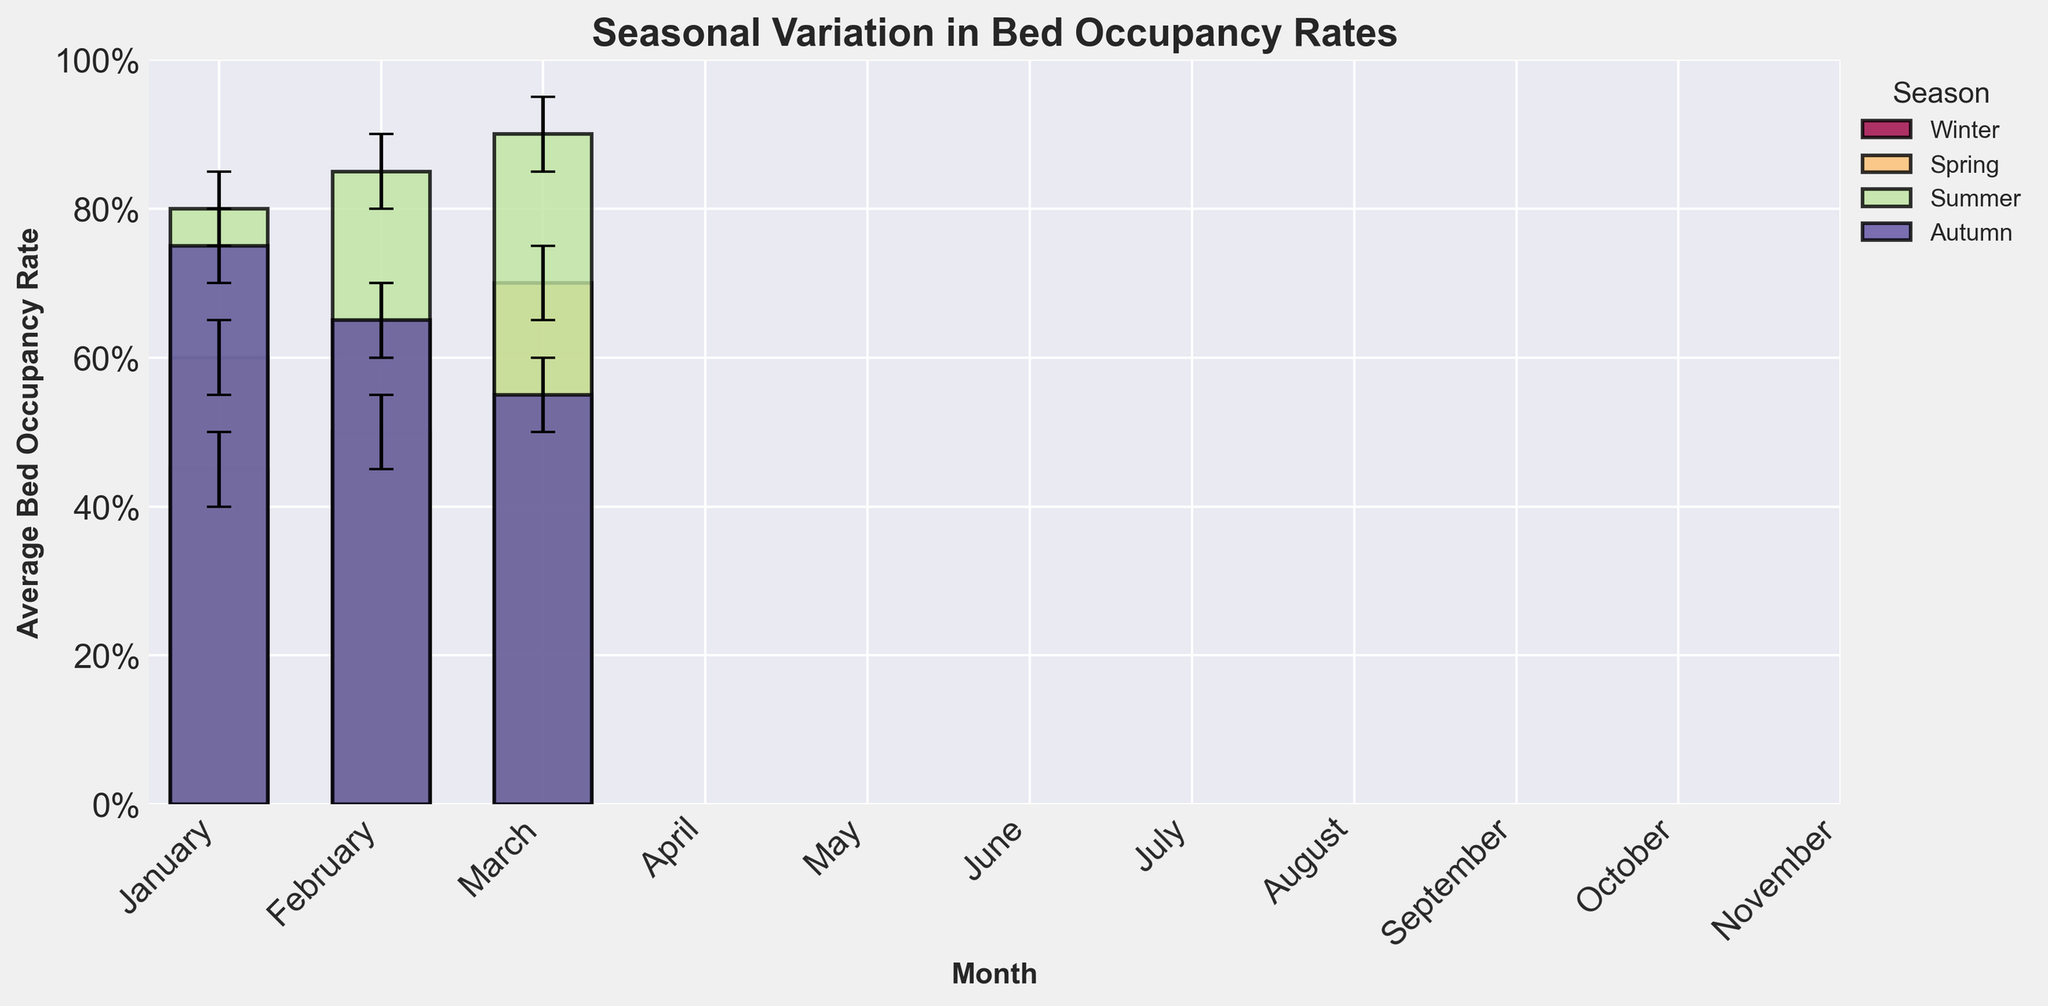what is the title of the chart? The title of the chart can be seen at the top and reads "Seasonal Variation in Bed Occupancy Rates".
Answer: Seasonal Variation in Bed Occupancy Rates how does bed occupancy rate trend through the year? Observing the average bed occupancy rates from January to November, rates start relatively low in January, gradually increase, peak during the summer months, and then decrease toward the end of the year in November.
Answer: Low in Winter, peaks in Summer, decreases in Autumn which month has the highest bed occupancy rate? The month with the highest average bed occupancy rate is August with a 0.90 rate.
Answer: August which season shows the most consistent occupancy rates? Spring has the most consistent occupancy rates, ranging only from 0.60 to 0.70.
Answer: Spring compare the average bed occupancy rate for June and September. The average bed occupancy rate for June is 0.80, while for September, it is 0.75. June has a higher rate by 0.05.
Answer: June is higher by 0.05 what is the range of the confidence interval for July? The confidence interval for July ranges from 0.80 to 0.90, giving a range of 0.10.
Answer: 0.10 which month has the largest confidence interval? August exhibits the largest confidence interval as it spans from 0.85 to 0.95, a range of 0.10.
Answer: August during which season does bed occupancy rate start decreasing significantly? Bed occupancy rates start decreasing significantly in the Autumn, particularly from September to October and continue to decrease through November.
Answer: Autumn how does the bed occupancy rate in February compare with April? In February, the average bed occupancy rate is 0.50, while in April, it is 0.65, making April's rate higher by 0.15.
Answer: April is higher by 0.15 how do confidence intervals reflect the uncertainty of measurements in the chart? Confidence intervals, represented as error bars in the chart, show the range within which the true bed occupancy rate is likely to fall. Wider intervals indicate more uncertainty, while narrower intervals show more precise measurements. For instance, January has a narrower interval compared to August, indicating lower uncertainty for January's estimates.
Answer: Error bars show measurement uncertainty 